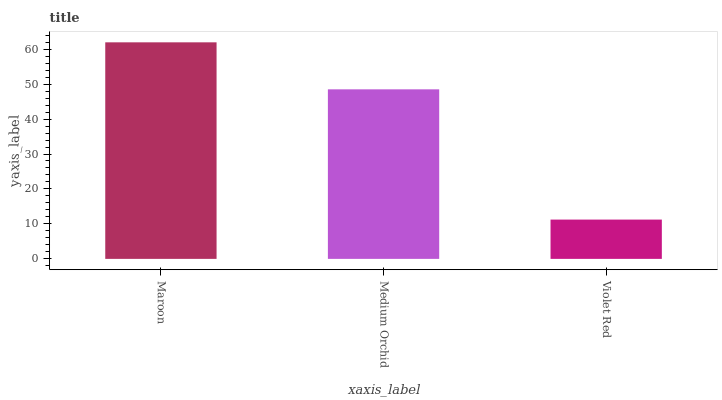Is Violet Red the minimum?
Answer yes or no. Yes. Is Maroon the maximum?
Answer yes or no. Yes. Is Medium Orchid the minimum?
Answer yes or no. No. Is Medium Orchid the maximum?
Answer yes or no. No. Is Maroon greater than Medium Orchid?
Answer yes or no. Yes. Is Medium Orchid less than Maroon?
Answer yes or no. Yes. Is Medium Orchid greater than Maroon?
Answer yes or no. No. Is Maroon less than Medium Orchid?
Answer yes or no. No. Is Medium Orchid the high median?
Answer yes or no. Yes. Is Medium Orchid the low median?
Answer yes or no. Yes. Is Maroon the high median?
Answer yes or no. No. Is Violet Red the low median?
Answer yes or no. No. 